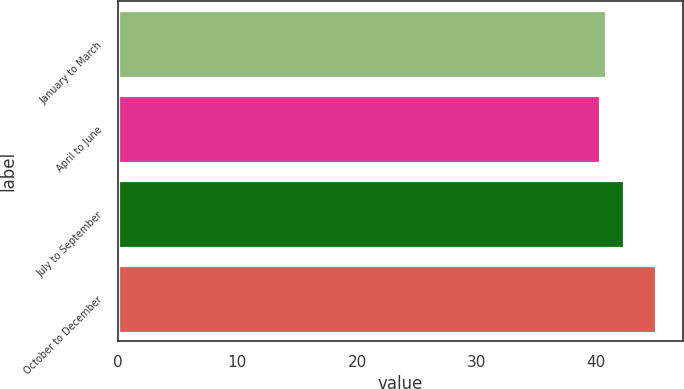Convert chart to OTSL. <chart><loc_0><loc_0><loc_500><loc_500><bar_chart><fcel>January to March<fcel>April to June<fcel>July to September<fcel>October to December<nl><fcel>40.79<fcel>40.33<fcel>42.27<fcel>44.96<nl></chart> 